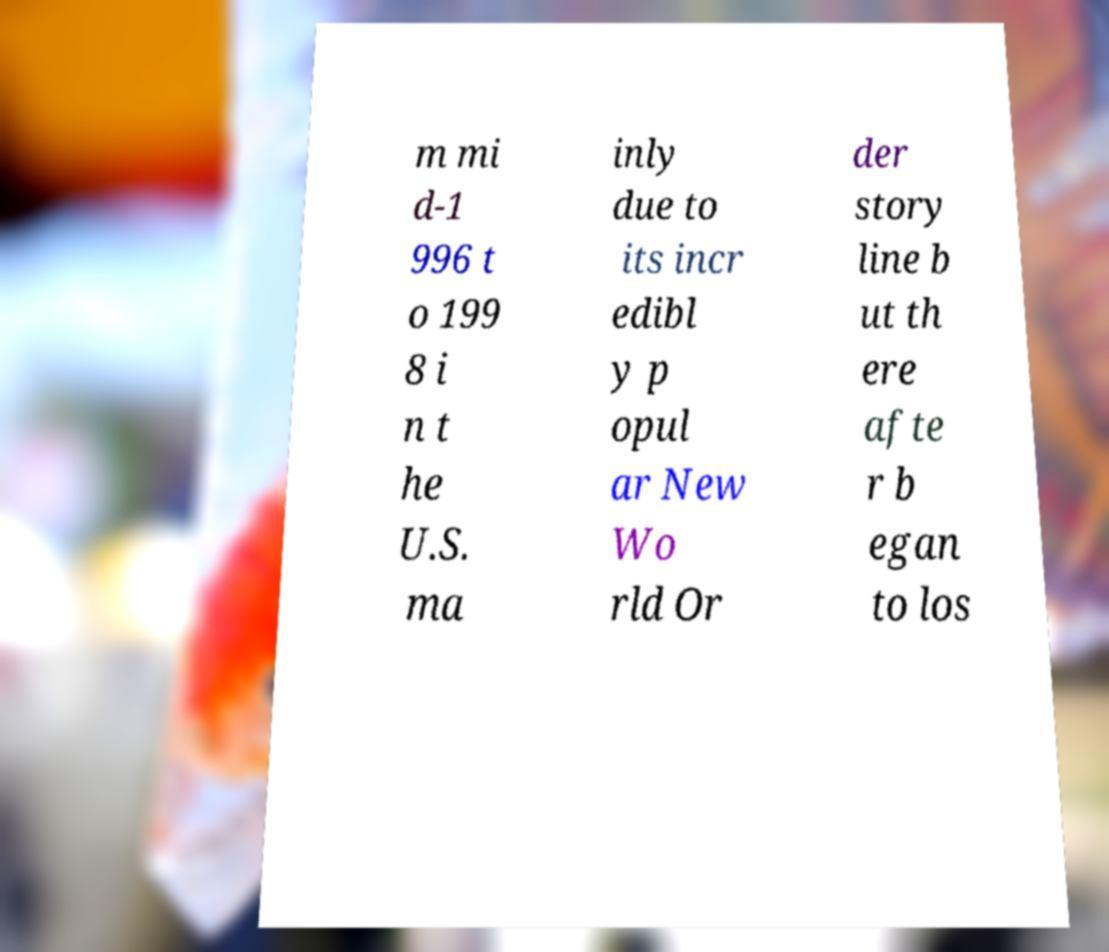Please identify and transcribe the text found in this image. m mi d-1 996 t o 199 8 i n t he U.S. ma inly due to its incr edibl y p opul ar New Wo rld Or der story line b ut th ere afte r b egan to los 